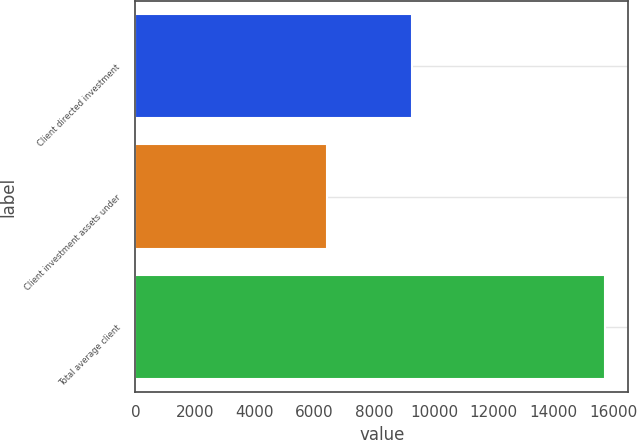Convert chart to OTSL. <chart><loc_0><loc_0><loc_500><loc_500><bar_chart><fcel>Client directed investment<fcel>Client investment assets under<fcel>Total average client<nl><fcel>9279<fcel>6432<fcel>15711<nl></chart> 